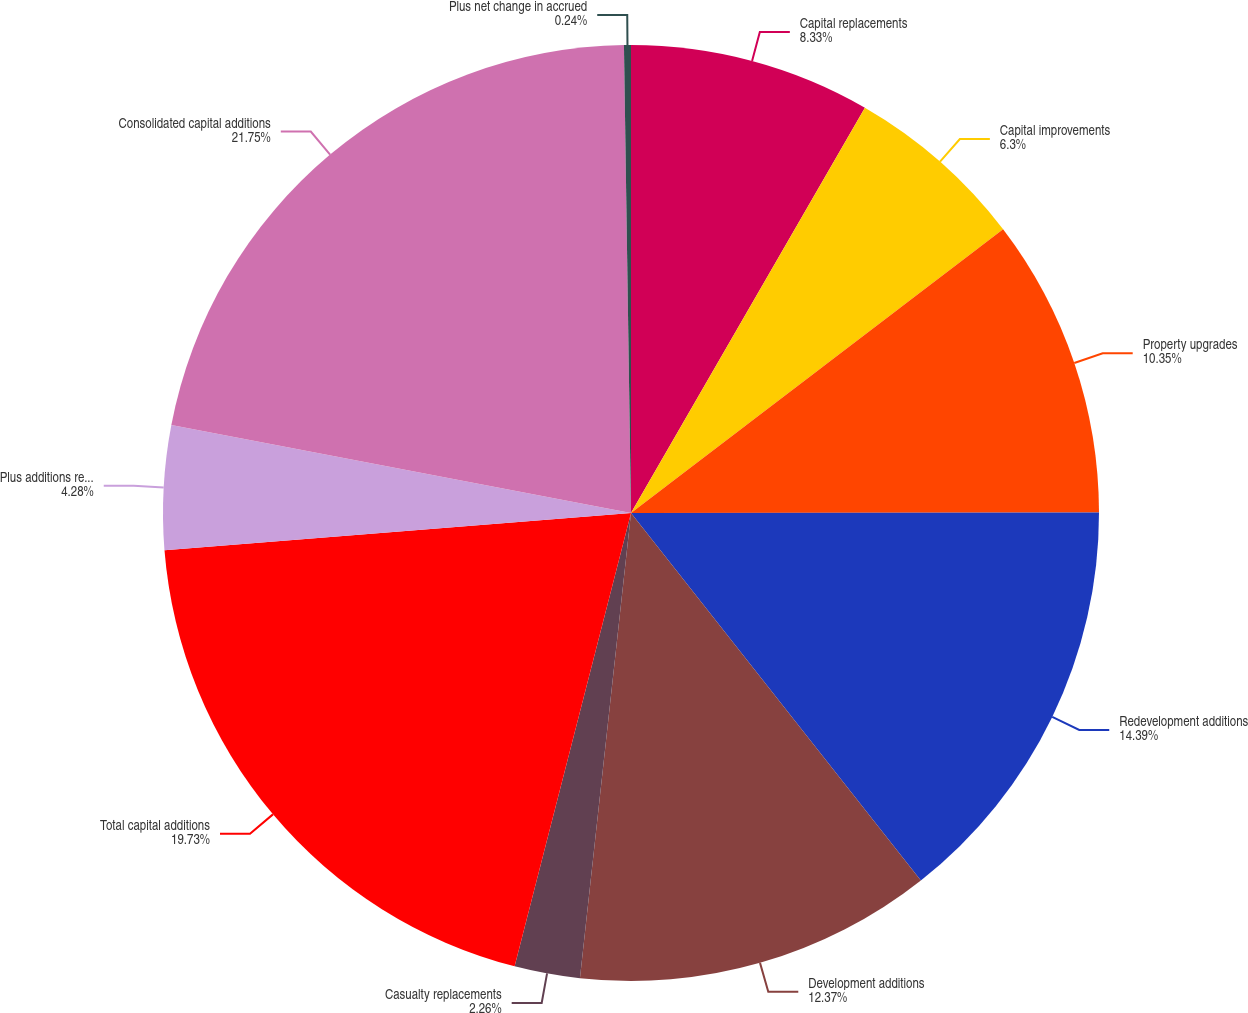Convert chart to OTSL. <chart><loc_0><loc_0><loc_500><loc_500><pie_chart><fcel>Capital replacements<fcel>Capital improvements<fcel>Property upgrades<fcel>Redevelopment additions<fcel>Development additions<fcel>Casualty replacements<fcel>Total capital additions<fcel>Plus additions related to<fcel>Consolidated capital additions<fcel>Plus net change in accrued<nl><fcel>8.33%<fcel>6.3%<fcel>10.35%<fcel>14.39%<fcel>12.37%<fcel>2.26%<fcel>19.73%<fcel>4.28%<fcel>21.75%<fcel>0.24%<nl></chart> 